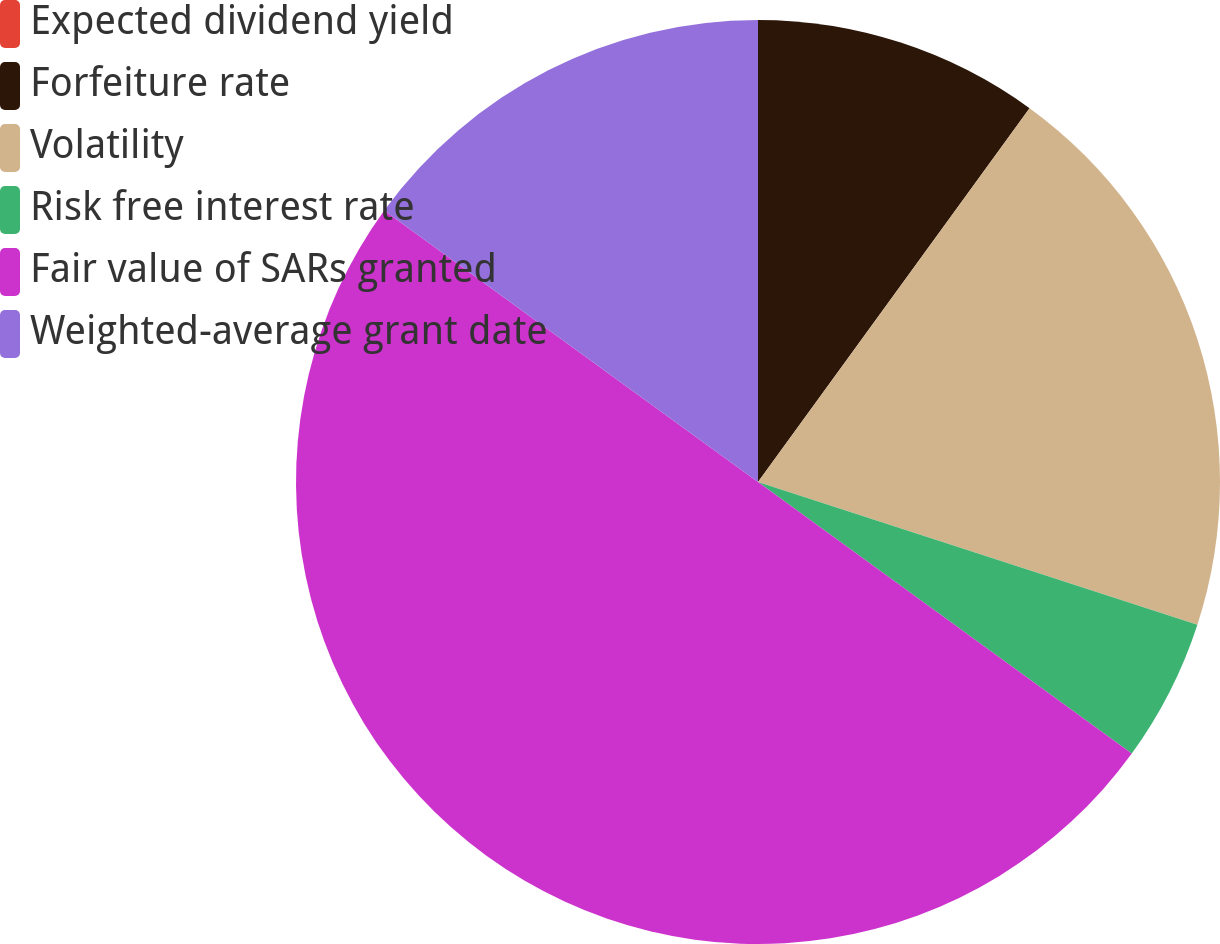Convert chart to OTSL. <chart><loc_0><loc_0><loc_500><loc_500><pie_chart><fcel>Expected dividend yield<fcel>Forfeiture rate<fcel>Volatility<fcel>Risk free interest rate<fcel>Fair value of SARs granted<fcel>Weighted-average grant date<nl><fcel>0.0%<fcel>10.0%<fcel>20.0%<fcel>5.0%<fcel>50.0%<fcel>15.0%<nl></chart> 